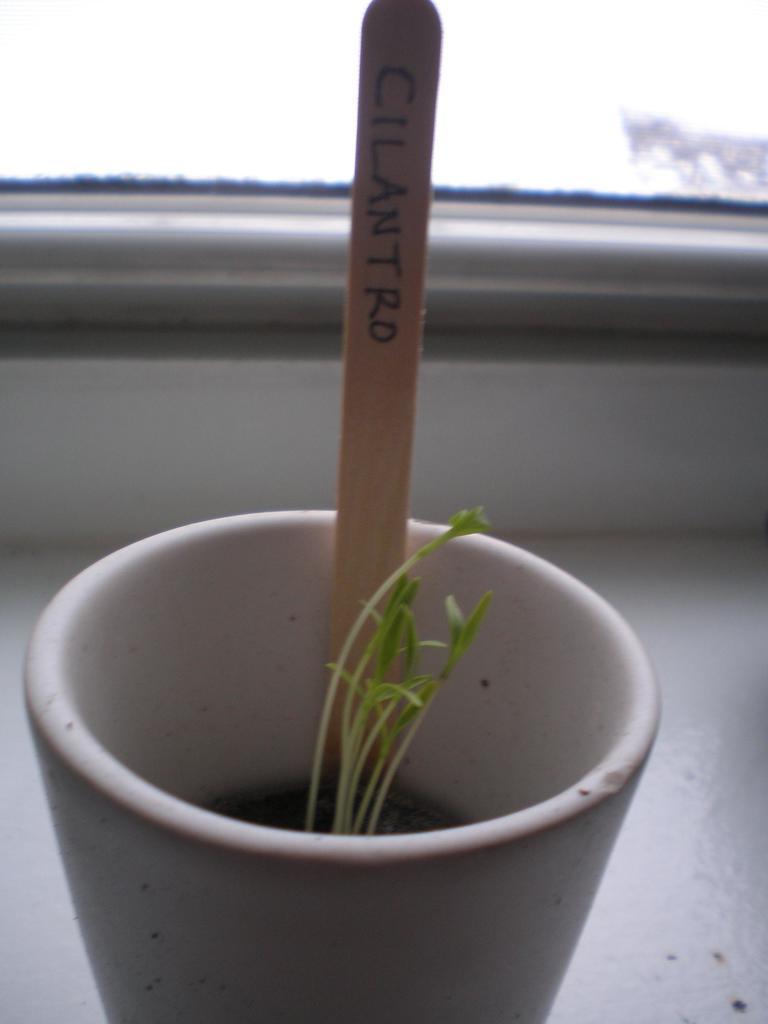Can you describe this image briefly? In this picture I can see at the bottom there are plants in a cup and there is a stick. 